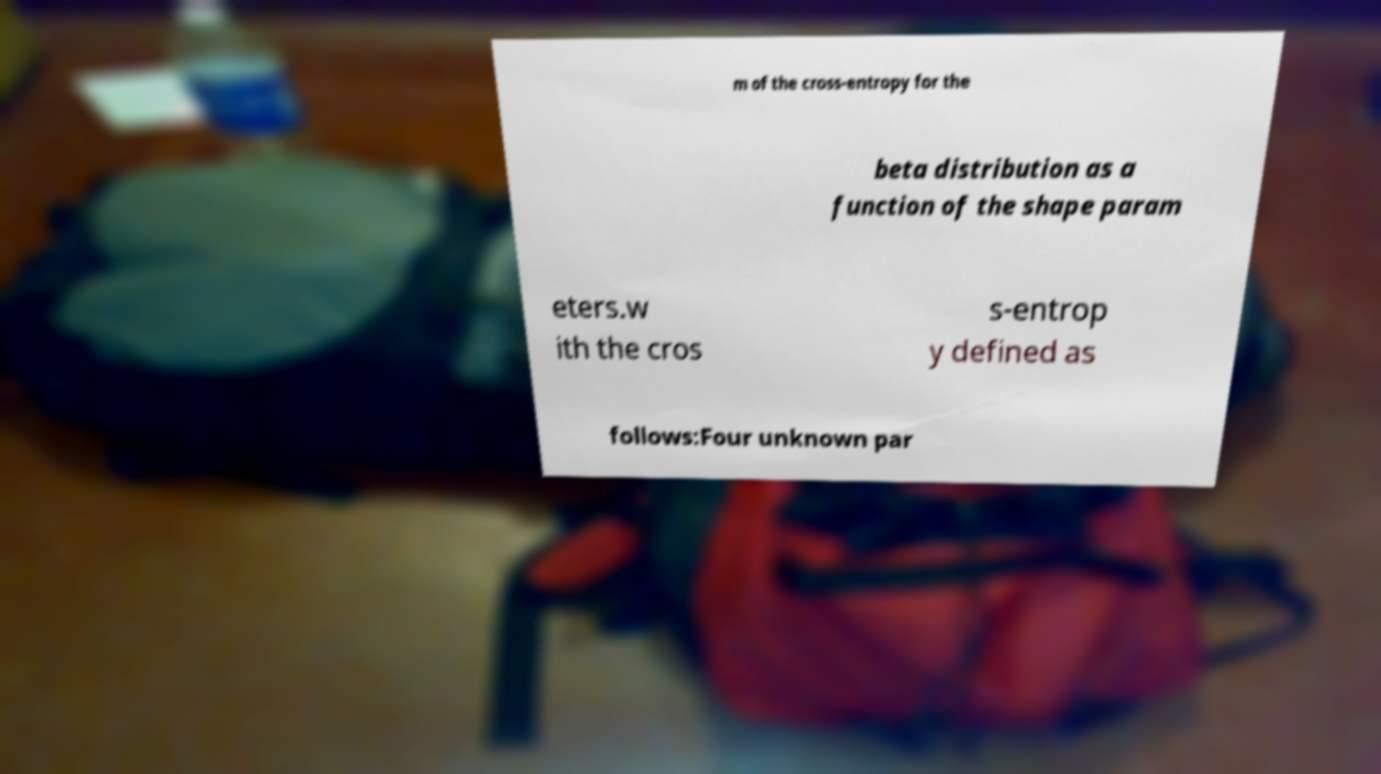Please read and relay the text visible in this image. What does it say? m of the cross-entropy for the beta distribution as a function of the shape param eters.w ith the cros s-entrop y defined as follows:Four unknown par 